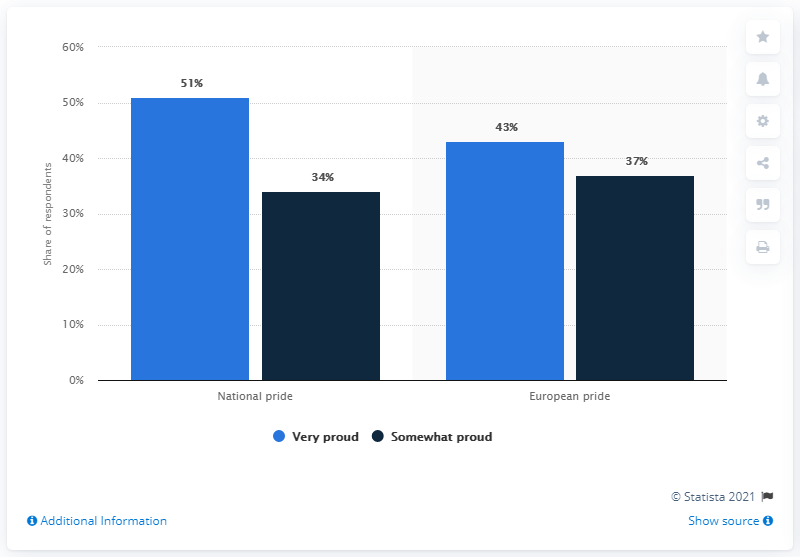Indicate a few pertinent items in this graphic. The average of very proud responses is 47. Very proud is the response that has the largest number of respondents. 